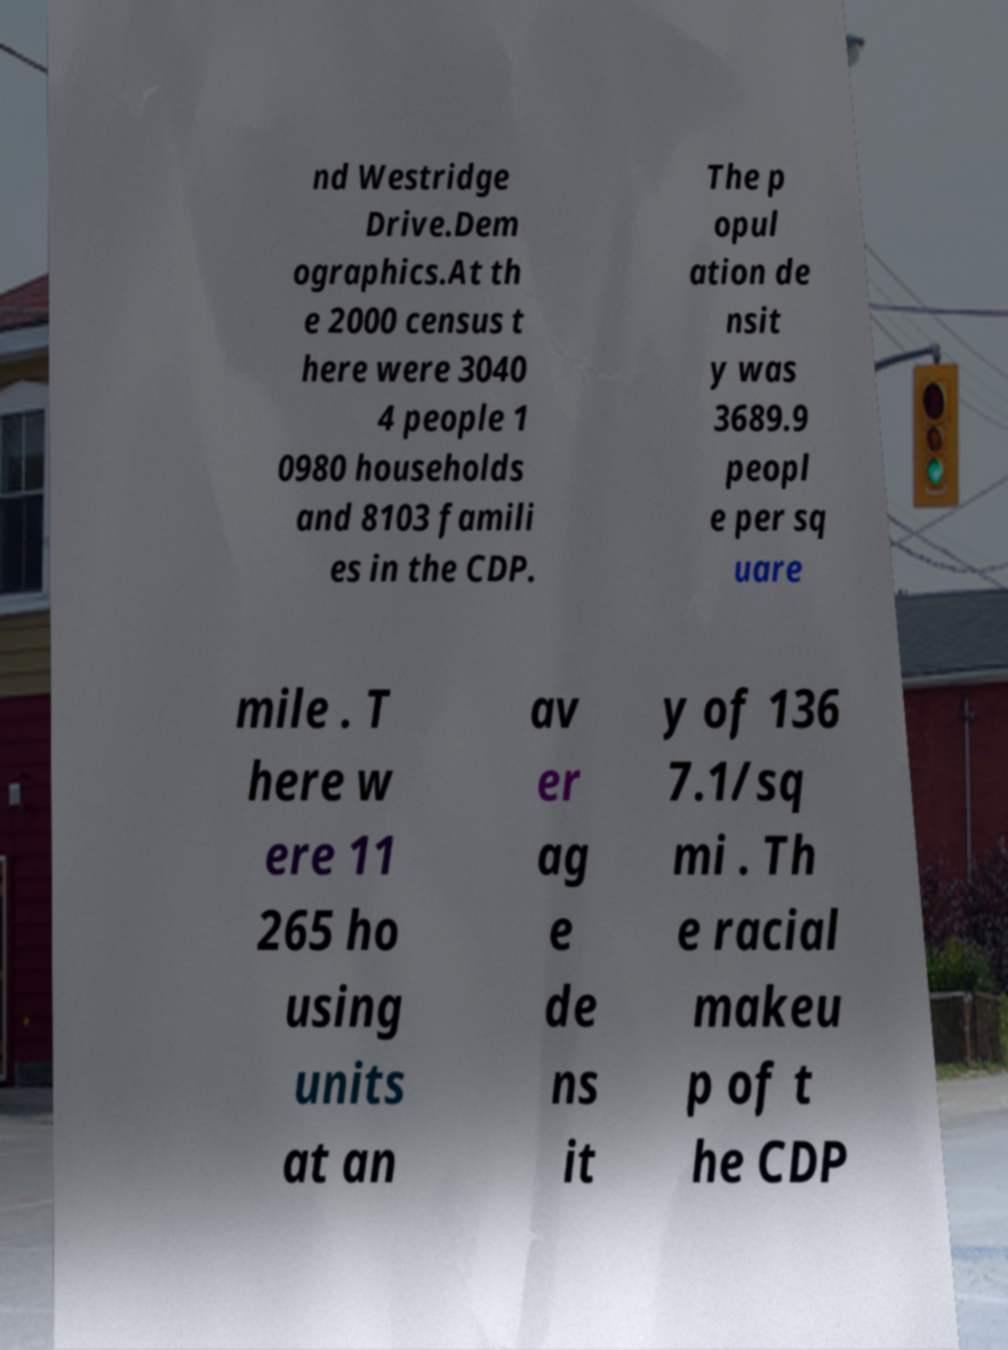Could you assist in decoding the text presented in this image and type it out clearly? nd Westridge Drive.Dem ographics.At th e 2000 census t here were 3040 4 people 1 0980 households and 8103 famili es in the CDP. The p opul ation de nsit y was 3689.9 peopl e per sq uare mile . T here w ere 11 265 ho using units at an av er ag e de ns it y of 136 7.1/sq mi . Th e racial makeu p of t he CDP 